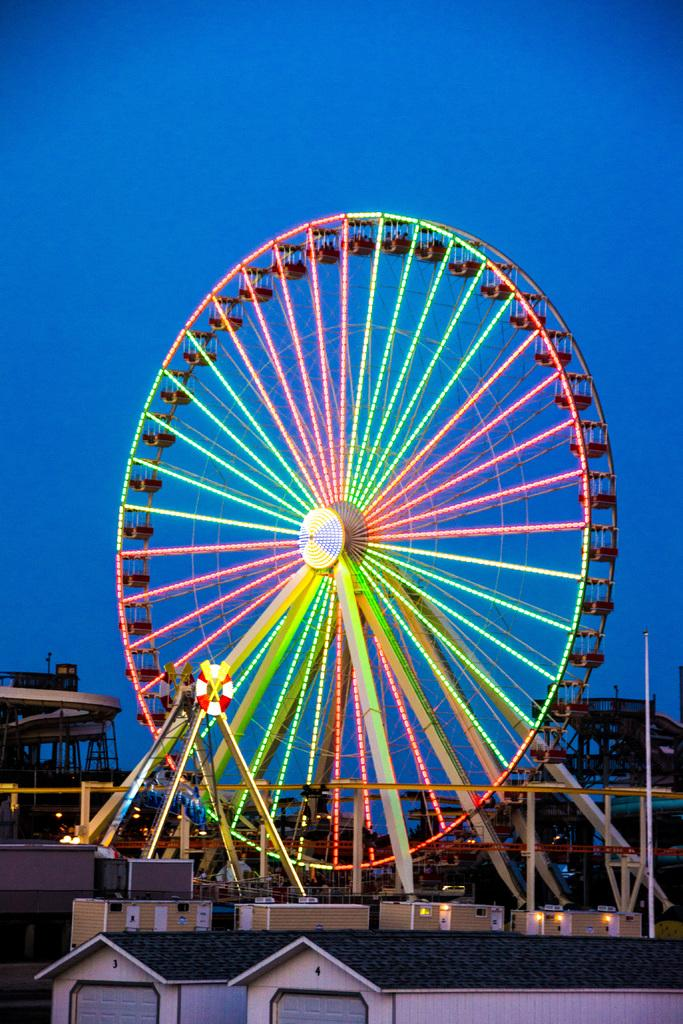What type of structures can be seen in the front of the image? There are houses in the front of the image. What can be found in the background of the image? There are amusement rides in the background of the image. How many snails can be seen crawling on the houses in the image? There are no snails visible in the image; it features houses and amusement rides. What statement does the image make about the location? The image does not make a specific statement about the location, as it only shows houses and amusement rides. 